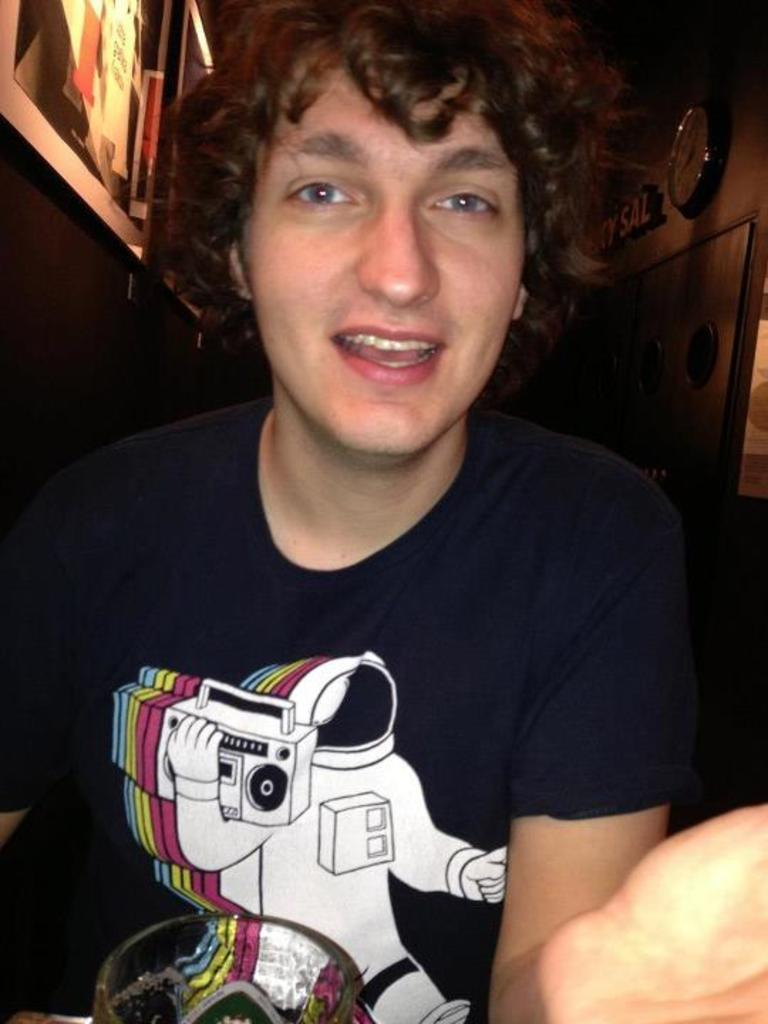What is the man in the image doing? The man is sitting in the image. Can you describe any objects or features on the wall in the image? There is a clock on the wall on the right side of the image. What type of brick is used to build the property in the image? There is no property or brick visible in the image; it only features a man sitting and a clock on the wall. 